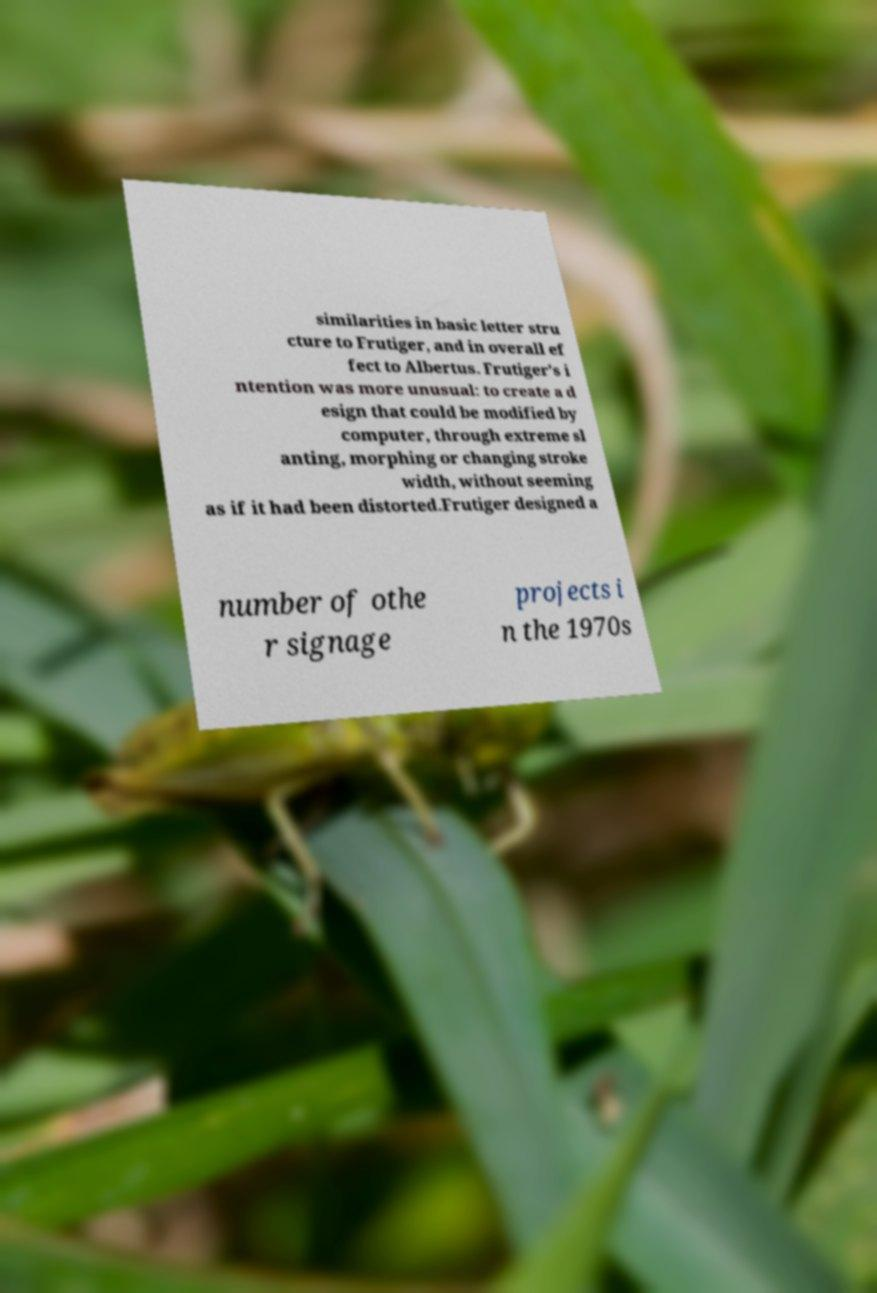There's text embedded in this image that I need extracted. Can you transcribe it verbatim? similarities in basic letter stru cture to Frutiger, and in overall ef fect to Albertus. Frutiger's i ntention was more unusual: to create a d esign that could be modified by computer, through extreme sl anting, morphing or changing stroke width, without seeming as if it had been distorted.Frutiger designed a number of othe r signage projects i n the 1970s 